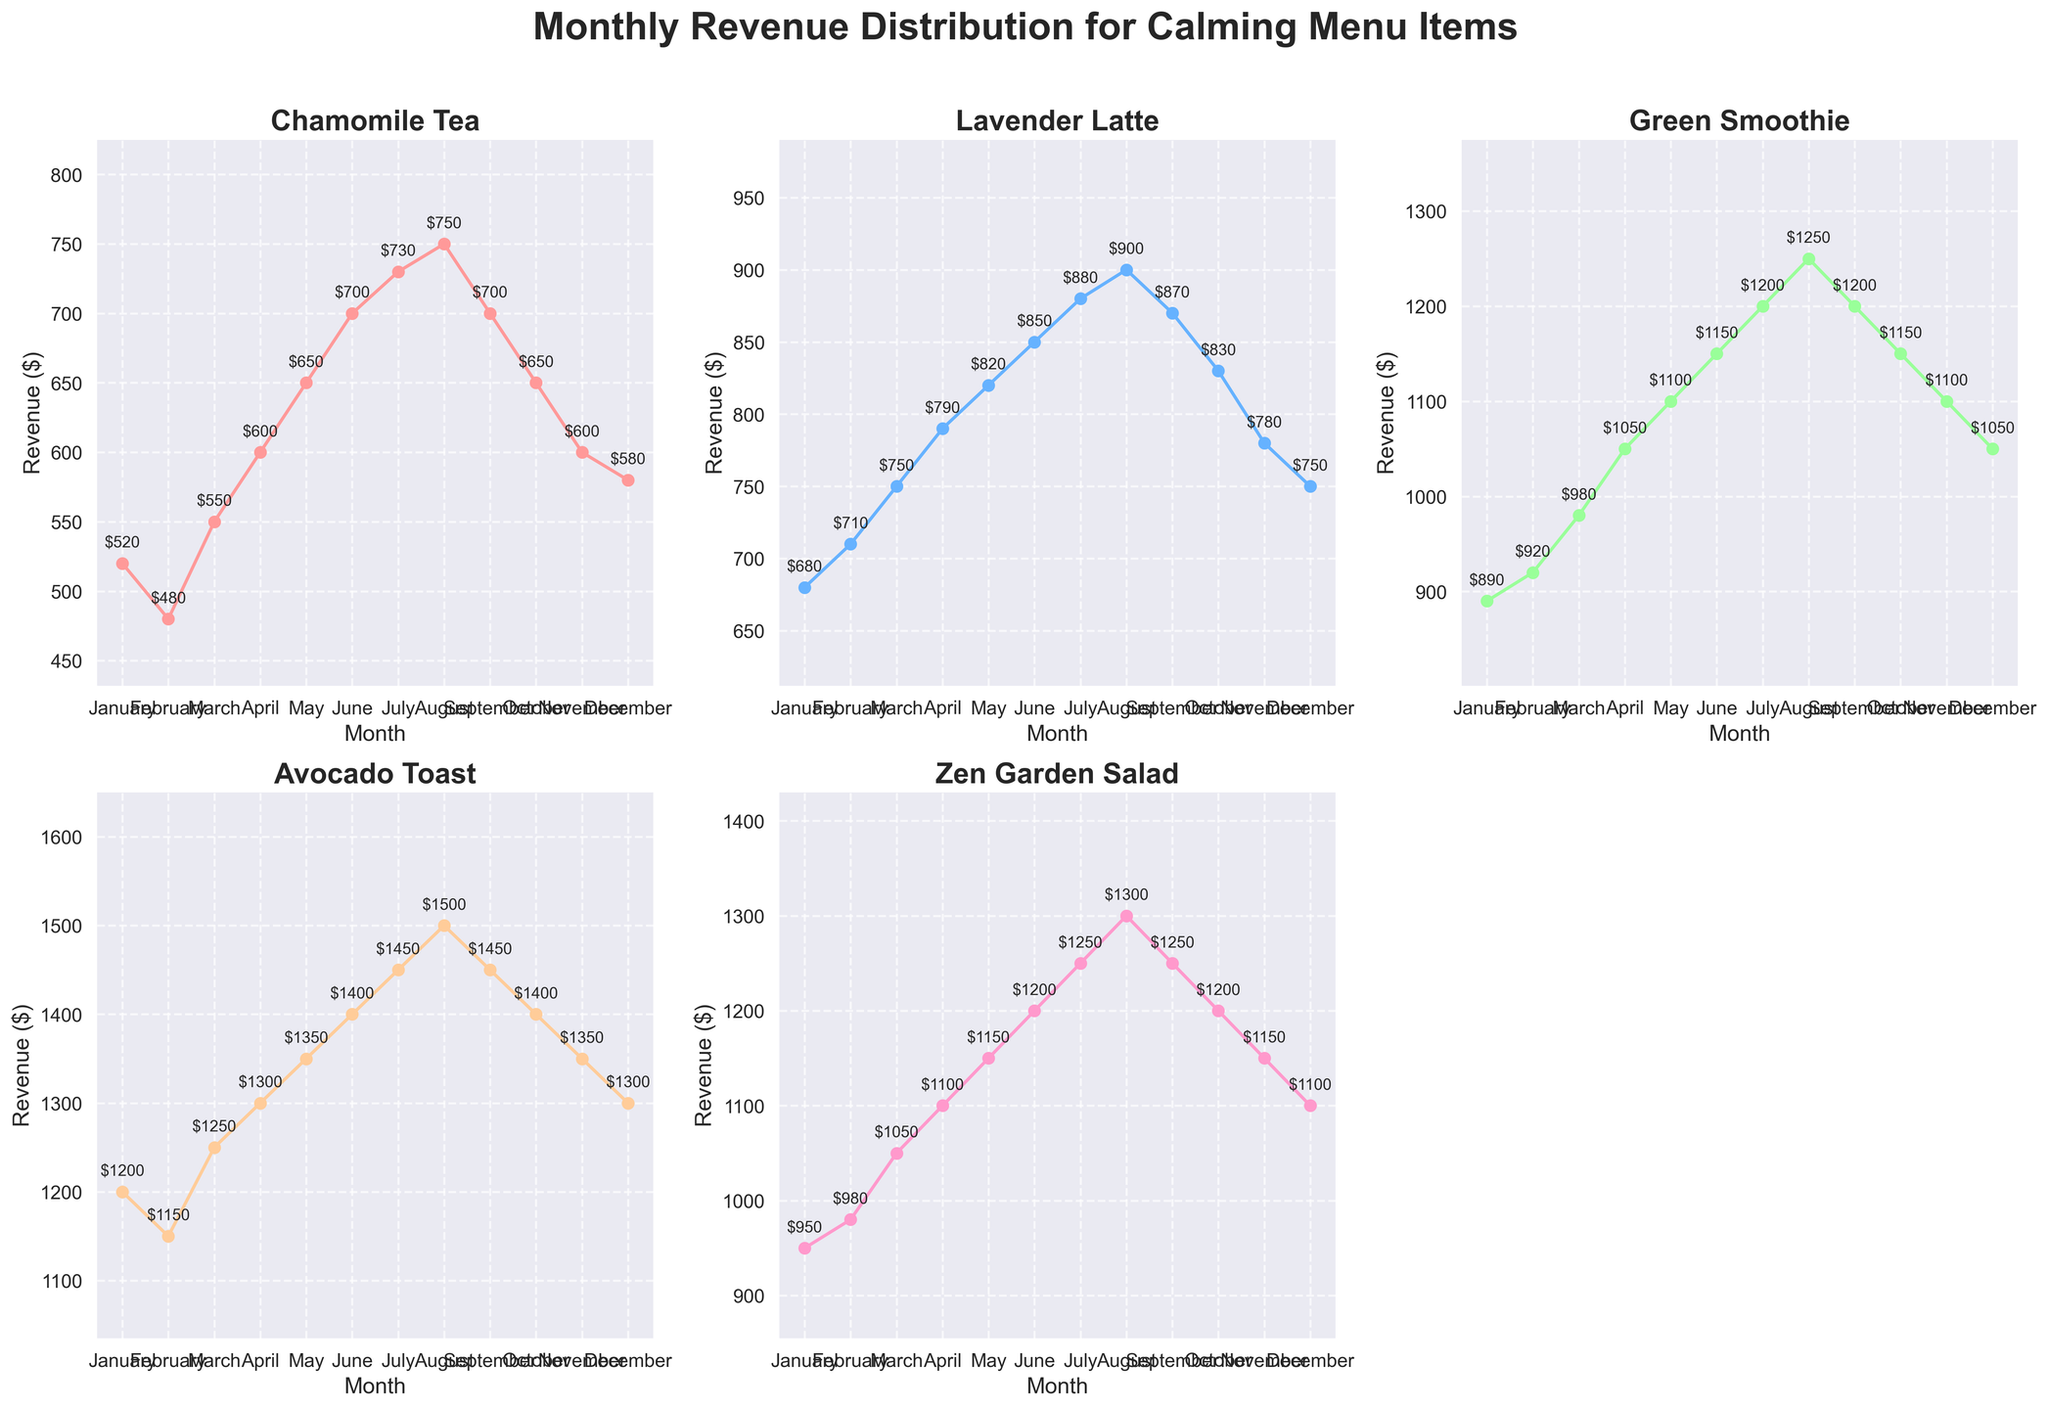How does the monthly revenue trend for Green Smoothie look throughout the year? The plot shows that the revenue for Green Smoothie increases steadily from January ($890) to August ($1250) and then slightly decreases towards the end of the year.
Answer: Increasing until August, then slight decrease Which calming menu item has the highest revenue in December? By looking at the plots, in December, Avocado Toast has the highest revenue at $1300 compared to the other items.
Answer: Avocado Toast What is the average monthly revenue for Chamomile Tea? Sum of monthly revenues for Chamomile Tea is (520 + 480 + 550 + 600 + 650 + 700 + 730 + 750 + 700 + 650 + 600 + 580) = 8230. Average = 8230 / 12.
Answer: $685.83 In which month did Avocado Toast first reach $1400? Observing the Avocado Toast plot, $1400 is first reached in June.
Answer: June How does the revenue of Zen Garden Salad in July compare to its revenue in January? Zen Garden Salad revenue in July is $1250, and in January it is $950. July's revenue is higher than January's by $300.
Answer: $300 higher in July What months show a decline in revenue for Chamomile Tea? From the plot of Chamomile Tea, the revenue declines in February, September, and December.
Answer: February, September, December What is the total revenue for Lavender Latte across June, July, and August? Adding the revenues for Lavender Latte from June ($850), July ($880), and August ($900): 850 + 880 + 900 = 2630.
Answer: $2630 What is the overall trend of Avocado Toast revenue throughout the year? Avocado Toast revenue shows a gradually increasing trend from January to peak in August, then a slight decrease towards December.
Answer: Increasing overall, peak in August, slight decline afterward Which month has the highest combined revenue for all the calming menu items? Calculate combined revenue for each month by summing the revenue of all items: for August: 750 + 900 + 1250 + 1500 + 1300 = 5700, which is the highest combined revenue.
Answer: August What is the difference between the highest and lowest monthly revenue for Zen Garden Salad? Highest value is $1300 in August, lowest is $950 in January. Difference = 1300 - 950 = 350.
Answer: $350 